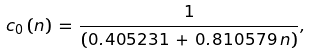<formula> <loc_0><loc_0><loc_500><loc_500>c _ { 0 } \left ( n \right ) \, = \, \frac { 1 } { \left ( 0 . 4 0 5 2 3 1 \, + \, 0 . 8 1 0 5 7 9 \, n \right ) } ,</formula> 